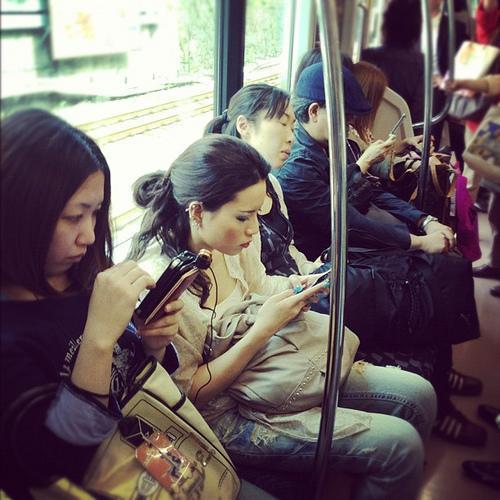How many phones are shown?
Give a very brief answer. 3. How many people are shown sleeping?
Give a very brief answer. 1. 